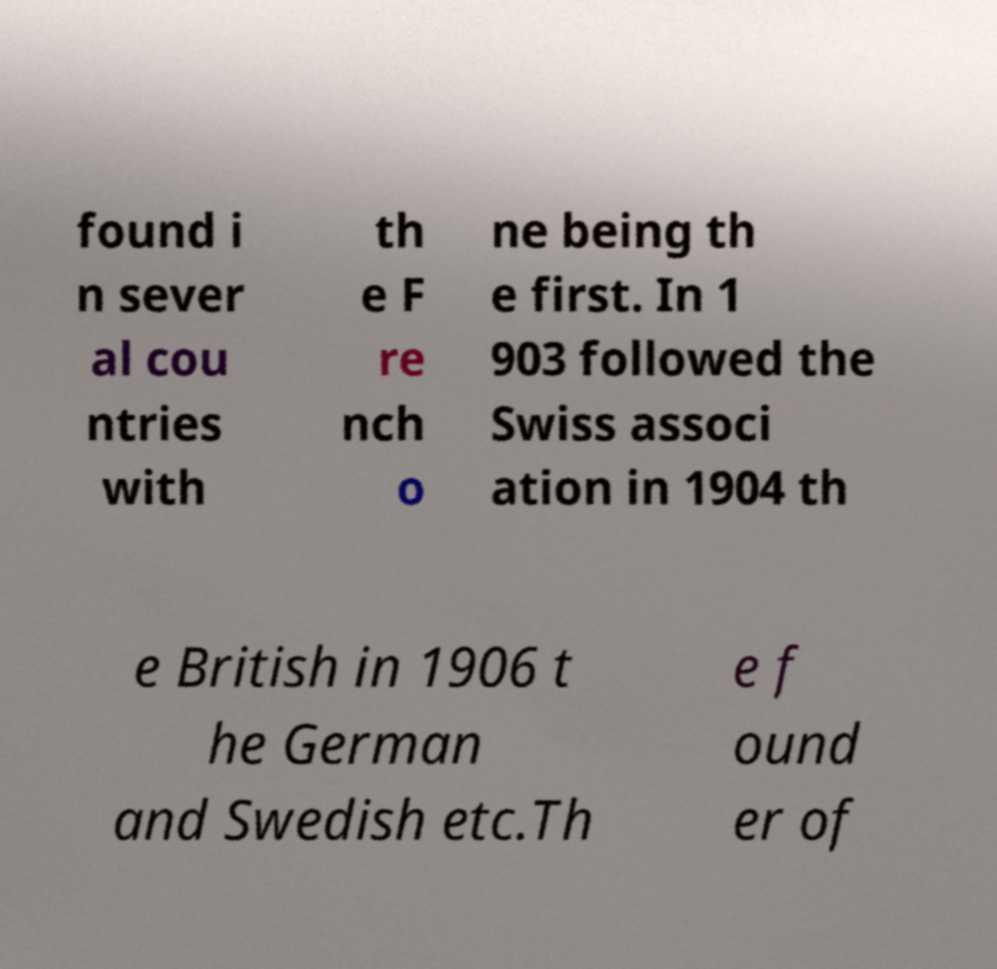Please read and relay the text visible in this image. What does it say? found i n sever al cou ntries with th e F re nch o ne being th e first. In 1 903 followed the Swiss associ ation in 1904 th e British in 1906 t he German and Swedish etc.Th e f ound er of 